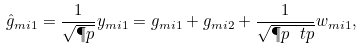Convert formula to latex. <formula><loc_0><loc_0><loc_500><loc_500>\hat { g } _ { m i 1 } = \frac { 1 } { \sqrt { \P p } } y _ { m i 1 } = g _ { m i 1 } + g _ { m i 2 } + \frac { 1 } { \sqrt { \P p \ t p } } w _ { m i 1 } ,</formula> 